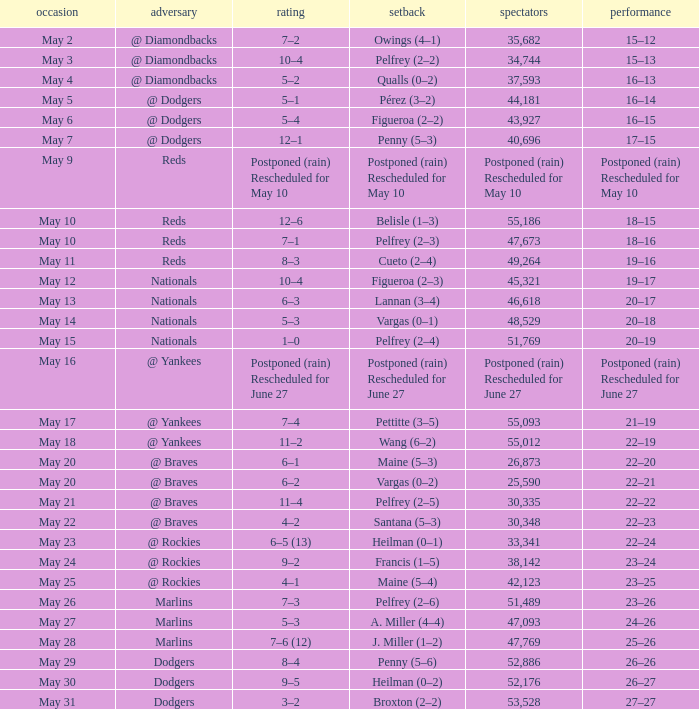What was the date when the 19-16 record occurred? May 11. 